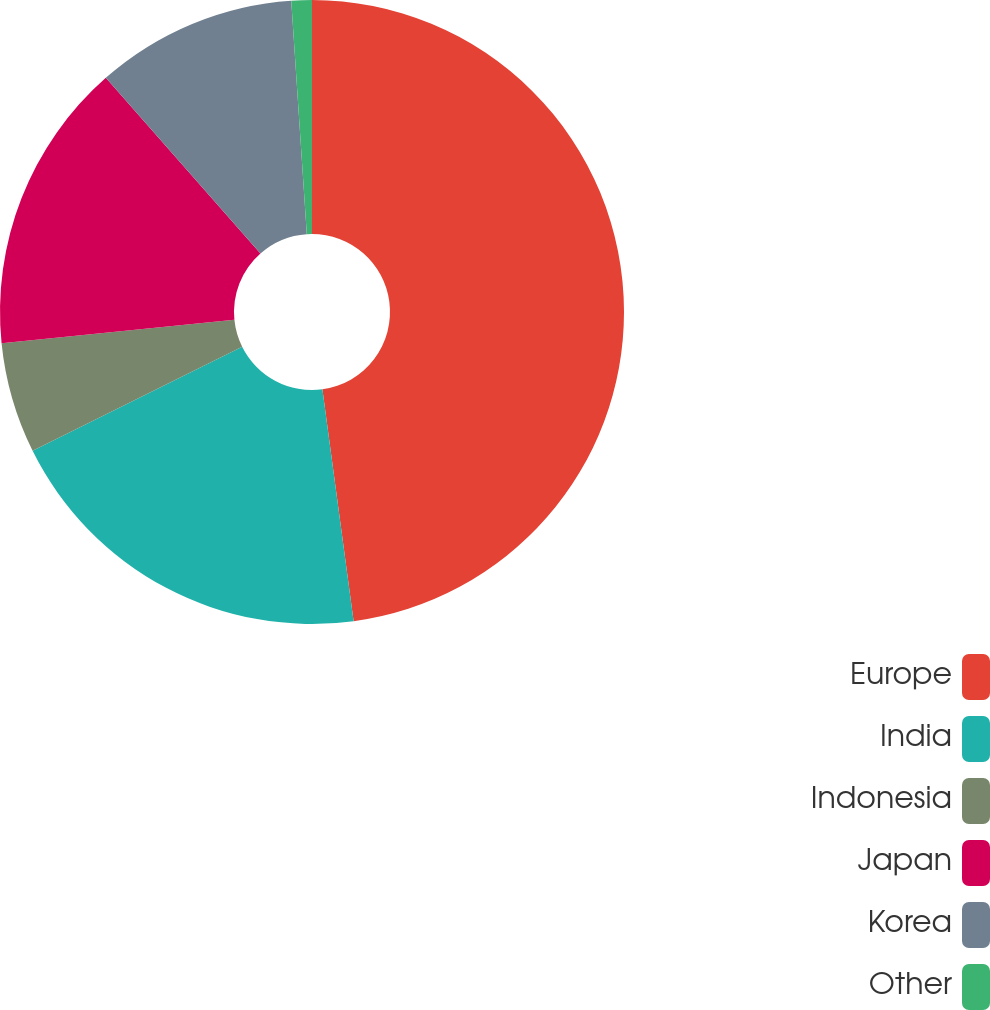<chart> <loc_0><loc_0><loc_500><loc_500><pie_chart><fcel>Europe<fcel>India<fcel>Indonesia<fcel>Japan<fcel>Korea<fcel>Other<nl><fcel>47.87%<fcel>19.79%<fcel>5.74%<fcel>15.11%<fcel>10.43%<fcel>1.06%<nl></chart> 